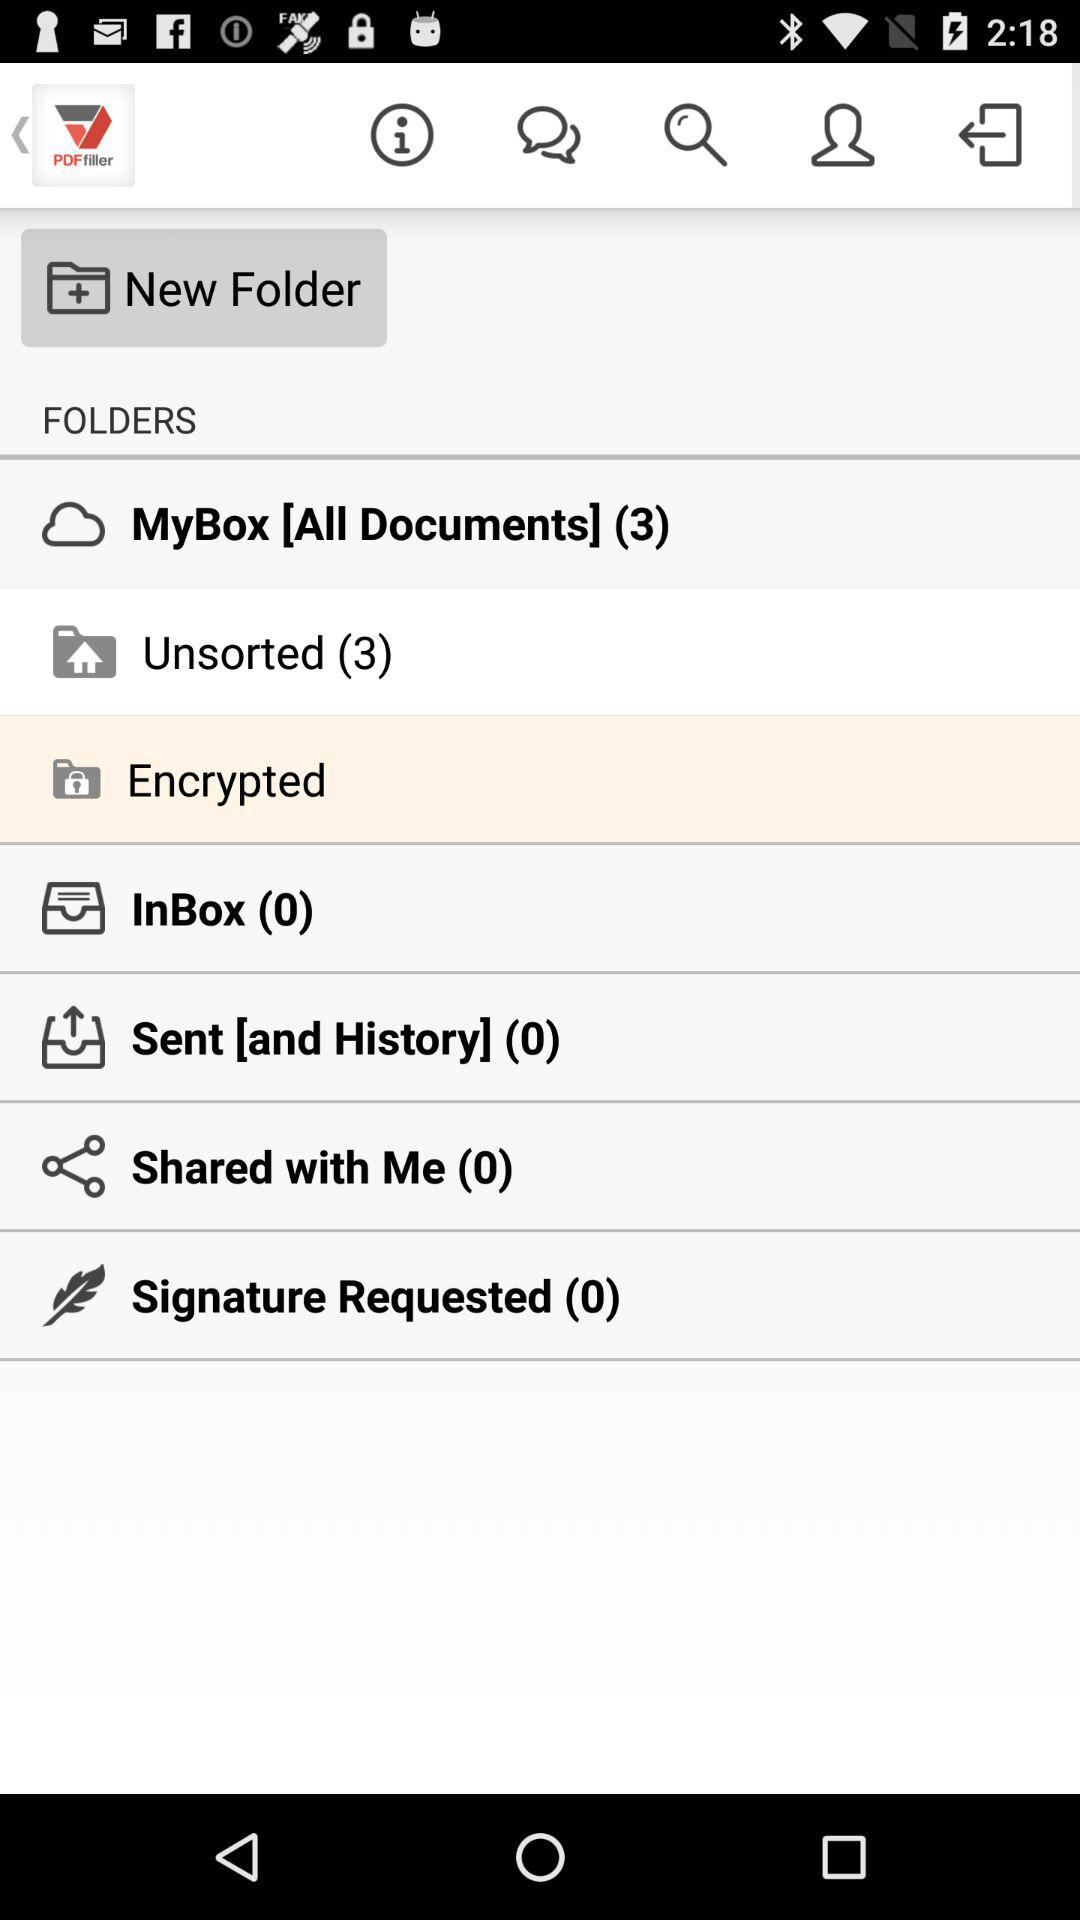How many total unread messages?
When the provided information is insufficient, respond with <no answer>. <no answer> 